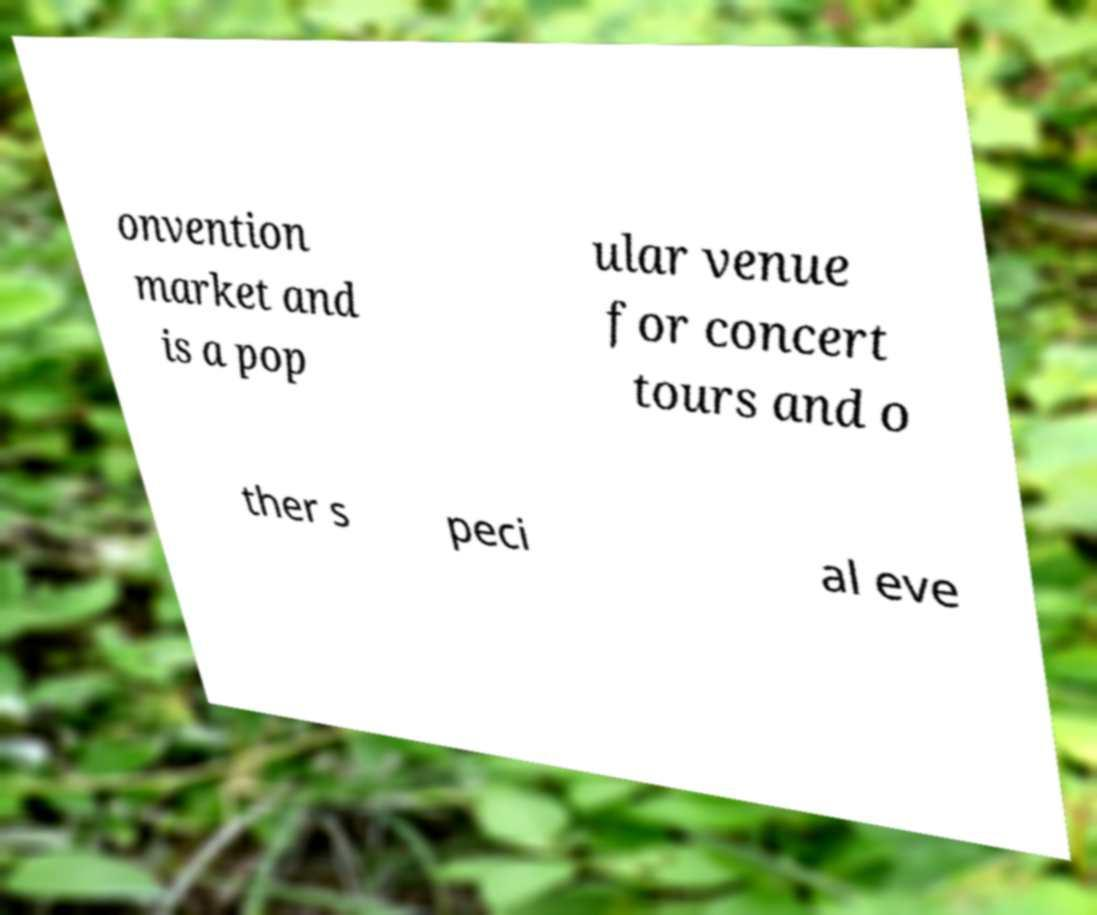Please identify and transcribe the text found in this image. onvention market and is a pop ular venue for concert tours and o ther s peci al eve 